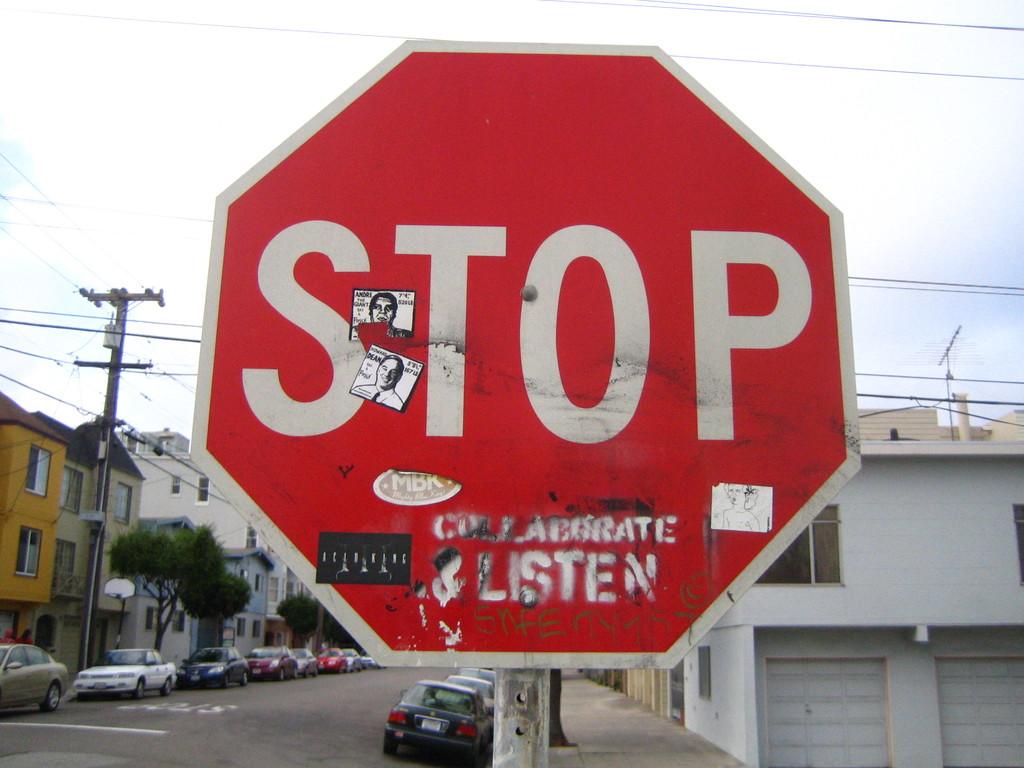What kind of sign is this?
Your answer should be very brief. Stop. What other word is on the stop sign?
Your answer should be very brief. Listen. 